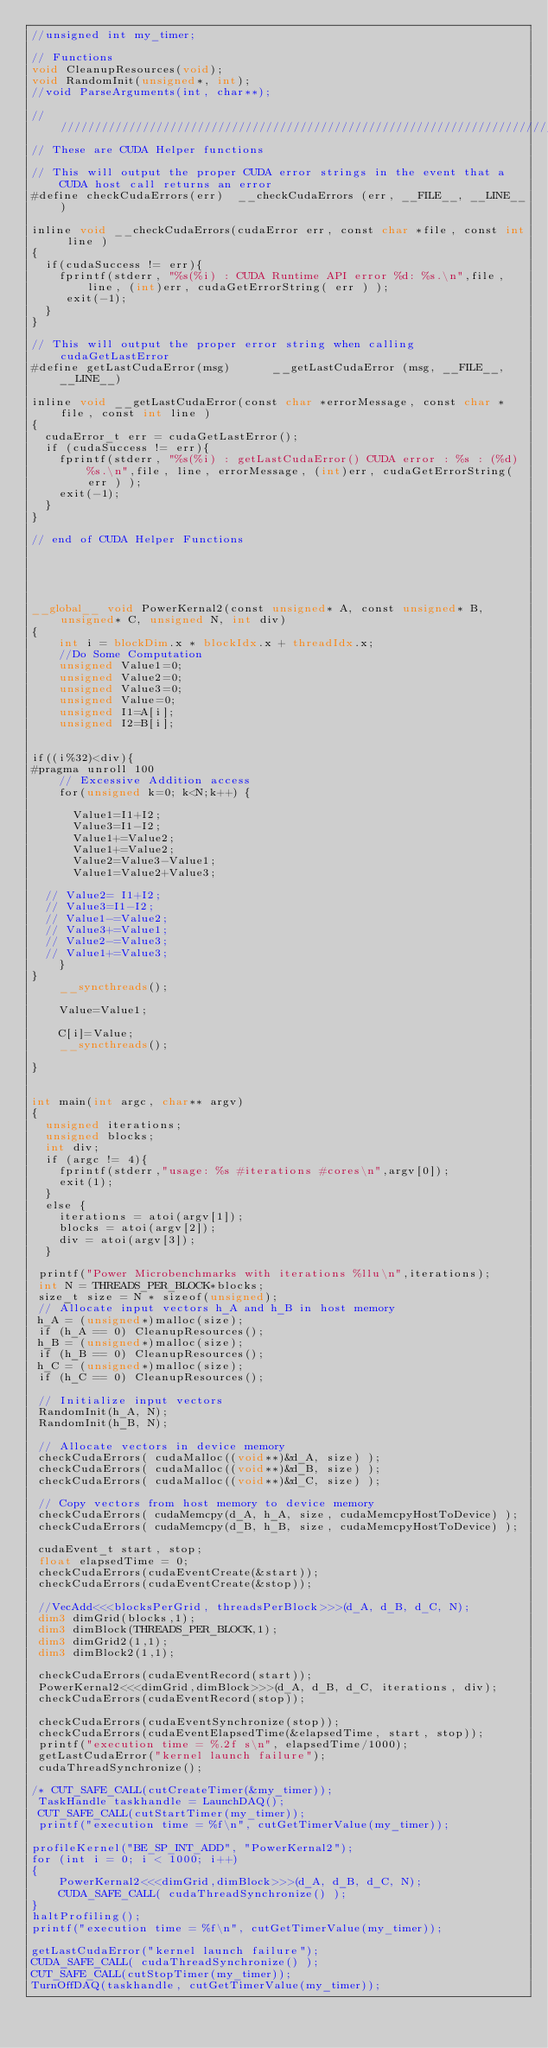<code> <loc_0><loc_0><loc_500><loc_500><_Cuda_>//unsigned int my_timer;

// Functions
void CleanupResources(void);
void RandomInit(unsigned*, int);
//void ParseArguments(int, char**);

////////////////////////////////////////////////////////////////////////////////
// These are CUDA Helper functions

// This will output the proper CUDA error strings in the event that a CUDA host call returns an error
#define checkCudaErrors(err)  __checkCudaErrors (err, __FILE__, __LINE__)

inline void __checkCudaErrors(cudaError err, const char *file, const int line )
{
  if(cudaSuccess != err){
	fprintf(stderr, "%s(%i) : CUDA Runtime API error %d: %s.\n",file, line, (int)err, cudaGetErrorString( err ) );
	 exit(-1);
  }
}

// This will output the proper error string when calling cudaGetLastError
#define getLastCudaError(msg)      __getLastCudaError (msg, __FILE__, __LINE__)

inline void __getLastCudaError(const char *errorMessage, const char *file, const int line )
{
  cudaError_t err = cudaGetLastError();
  if (cudaSuccess != err){
	fprintf(stderr, "%s(%i) : getLastCudaError() CUDA error : %s : (%d) %s.\n",file, line, errorMessage, (int)err, cudaGetErrorString( err ) );
	exit(-1);
  }
}

// end of CUDA Helper Functions





__global__ void PowerKernal2(const unsigned* A, const unsigned* B, unsigned* C, unsigned N, int div)
{
    int i = blockDim.x * blockIdx.x + threadIdx.x;
    //Do Some Computation
    unsigned Value1=0;
    unsigned Value2=0;
    unsigned Value3=0;
    unsigned Value=0;
    unsigned I1=A[i];
    unsigned I2=B[i];


if((i%32)<div){
#pragma unroll 100
    // Excessive Addition access
    for(unsigned k=0; k<N;k++) {

      Value1=I1+I2;
      Value3=I1-I2;
      Value1+=Value2;
      Value1+=Value2;
      Value2=Value3-Value1;
      Value1=Value2+Value3;

  // Value2= I1+I2;
  // Value3=I1-I2;
  // Value1-=Value2;
  // Value3+=Value1;
  // Value2-=Value3;
  // Value1+=Value3;
    }
}
    __syncthreads();
 
    Value=Value1;

    C[i]=Value;
    __syncthreads();

}


int main(int argc, char** argv)
{
  unsigned iterations;
  unsigned blocks;
  int div;
  if (argc != 4){
    fprintf(stderr,"usage: %s #iterations #cores\n",argv[0]);
    exit(1);
  }
  else {
    iterations = atoi(argv[1]);
    blocks = atoi(argv[2]);
    div = atoi(argv[3]);
  }
 
 printf("Power Microbenchmarks with iterations %llu\n",iterations);
 int N = THREADS_PER_BLOCK*blocks;
 size_t size = N * sizeof(unsigned);
 // Allocate input vectors h_A and h_B in host memory
 h_A = (unsigned*)malloc(size);
 if (h_A == 0) CleanupResources();
 h_B = (unsigned*)malloc(size);
 if (h_B == 0) CleanupResources();
 h_C = (unsigned*)malloc(size);
 if (h_C == 0) CleanupResources();

 // Initialize input vectors
 RandomInit(h_A, N);
 RandomInit(h_B, N);

 // Allocate vectors in device memory
 checkCudaErrors( cudaMalloc((void**)&d_A, size) );
 checkCudaErrors( cudaMalloc((void**)&d_B, size) );
 checkCudaErrors( cudaMalloc((void**)&d_C, size) );

 // Copy vectors from host memory to device memory
 checkCudaErrors( cudaMemcpy(d_A, h_A, size, cudaMemcpyHostToDevice) );
 checkCudaErrors( cudaMemcpy(d_B, h_B, size, cudaMemcpyHostToDevice) );

 cudaEvent_t start, stop;                   
 float elapsedTime = 0;                     
 checkCudaErrors(cudaEventCreate(&start));  
 checkCudaErrors(cudaEventCreate(&stop));

 //VecAdd<<<blocksPerGrid, threadsPerBlock>>>(d_A, d_B, d_C, N);
 dim3 dimGrid(blocks,1);
 dim3 dimBlock(THREADS_PER_BLOCK,1);
 dim3 dimGrid2(1,1);
 dim3 dimBlock2(1,1);

 checkCudaErrors(cudaEventRecord(start));              
 PowerKernal2<<<dimGrid,dimBlock>>>(d_A, d_B, d_C, iterations, div);  
 checkCudaErrors(cudaEventRecord(stop));               
 
 checkCudaErrors(cudaEventSynchronize(stop));           
 checkCudaErrors(cudaEventElapsedTime(&elapsedTime, start, stop));  
 printf("execution time = %.2f s\n", elapsedTime/1000);  
 getLastCudaError("kernel launch failure");              
 cudaThreadSynchronize(); 

/* CUT_SAFE_CALL(cutCreateTimer(&my_timer)); 
 TaskHandle taskhandle = LaunchDAQ();
 CUT_SAFE_CALL(cutStartTimer(my_timer)); 
 printf("execution time = %f\n", cutGetTimerValue(my_timer));

profileKernel("BE_SP_INT_ADD", "PowerKernal2");
for (int i = 0; i < 1000; i++)
{
	PowerKernal2<<<dimGrid,dimBlock>>>(d_A, d_B, d_C, N);
	CUDA_SAFE_CALL( cudaThreadSynchronize() );
}
haltProfiling();
printf("execution time = %f\n", cutGetTimerValue(my_timer));

getLastCudaError("kernel launch failure");
CUDA_SAFE_CALL( cudaThreadSynchronize() );
CUT_SAFE_CALL(cutStopTimer(my_timer));
TurnOffDAQ(taskhandle, cutGetTimerValue(my_timer));</code> 